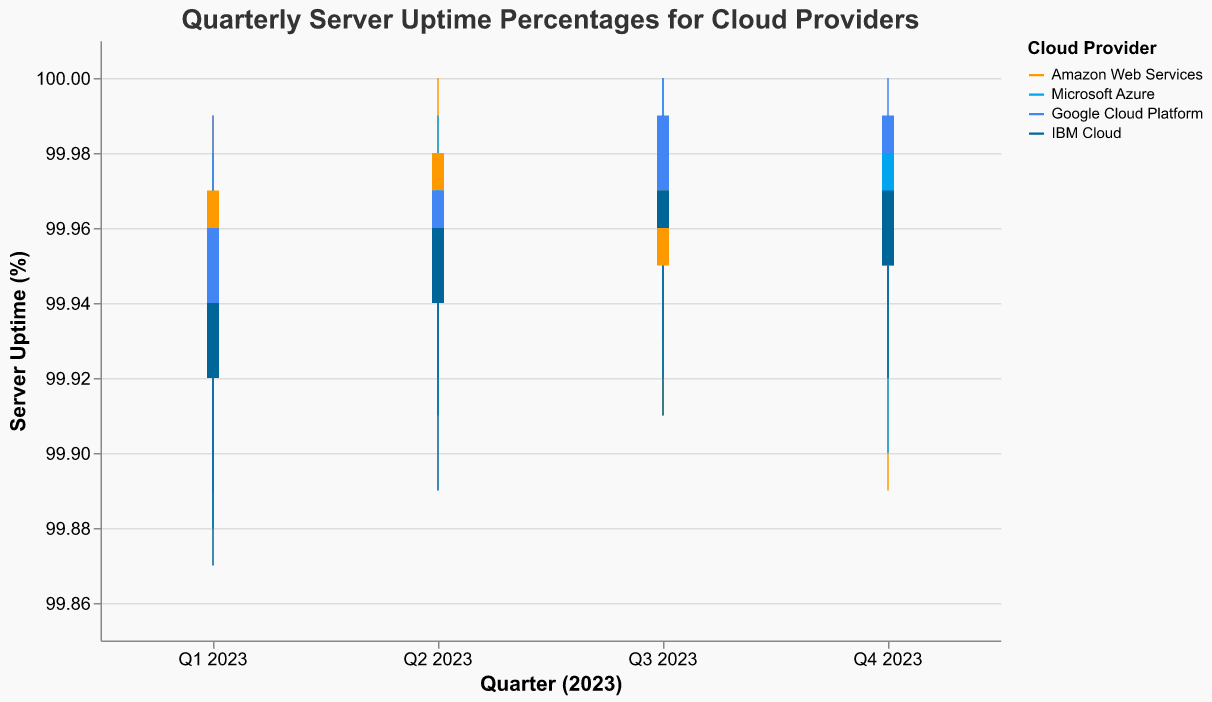What is the title of the figure? The title is displayed at the top of the figure and it reads "Quarterly Server Uptime Percentages for Cloud Providers".
Answer: Quarterly Server Uptime Percentages for Cloud Providers Which cloud provider has the highest server uptime in Q2 2023? For Q2 2023, the highest uptime value can be observed from the "High" values for each provider. AWS, Azure, and Google Cloud Platform all have "High" values of 100%.
Answer: AWS, Azure, Google Cloud Platform What is the lowest server uptime for IBM Cloud in Q4 2023? The lowest uptime for IBM Cloud in Q4 2023 can be found from the "Low" value for that quarter, which is 99.92%.
Answer: 99.92% Compare the median server uptime values between Q1 2023 and Q3 2023 for AWS. The median value for each group in an OHLC chart is the "Close" value. For AWS, the "Close" values for Q1 and Q3 2023 are 99.97% and 99.95% respectively.
Answer: Q1 2023: 99.97%, Q3 2023: 99.95% Which cloud provider experienced the largest range of server uptime in Q1 2023? The range is found by subtracting the "Low" value from the "High" value for each provider. For Q1 2023, AWS has a range of 0.09, Azure has 0.10, Google Cloud has 0.10, and IBM Cloud has 0.10. So, there's a tie among Azure, Google Cloud, and IBM Cloud.
Answer: Microsoft Azure, Google Cloud Platform, IBM Cloud What was the closing server uptime for Microsoft's Azure in Q4 2023? The "Close" value for Microsoft Azure in Q4 2023 is displayed as 99.96%.
Answer: 99.96% Did Google Cloud Platform's server uptime ever reach 100% across any of the quarters in 2023? Checking the "High" values for GCP across all quarters, 100% is reached in Q3 and Q4 2023.
Answer: Yes Between AWS and IBM Cloud, which had a higher median uptime in Q2 2023? The median uptime is the "Close" value. For Q2 2023, AWS has a "Close" value of 99.98% and IBM Cloud has a "Close" value of 99.96%. So, AWS had a higher median uptime.
Answer: AWS By how much did Azure's highest uptime change from Q1 to Q2 in 2023? The "High" value for Azure in Q1 is 99.98% and in Q2 it is 99.99%. The difference is 0.01%.
Answer: 0.01% 